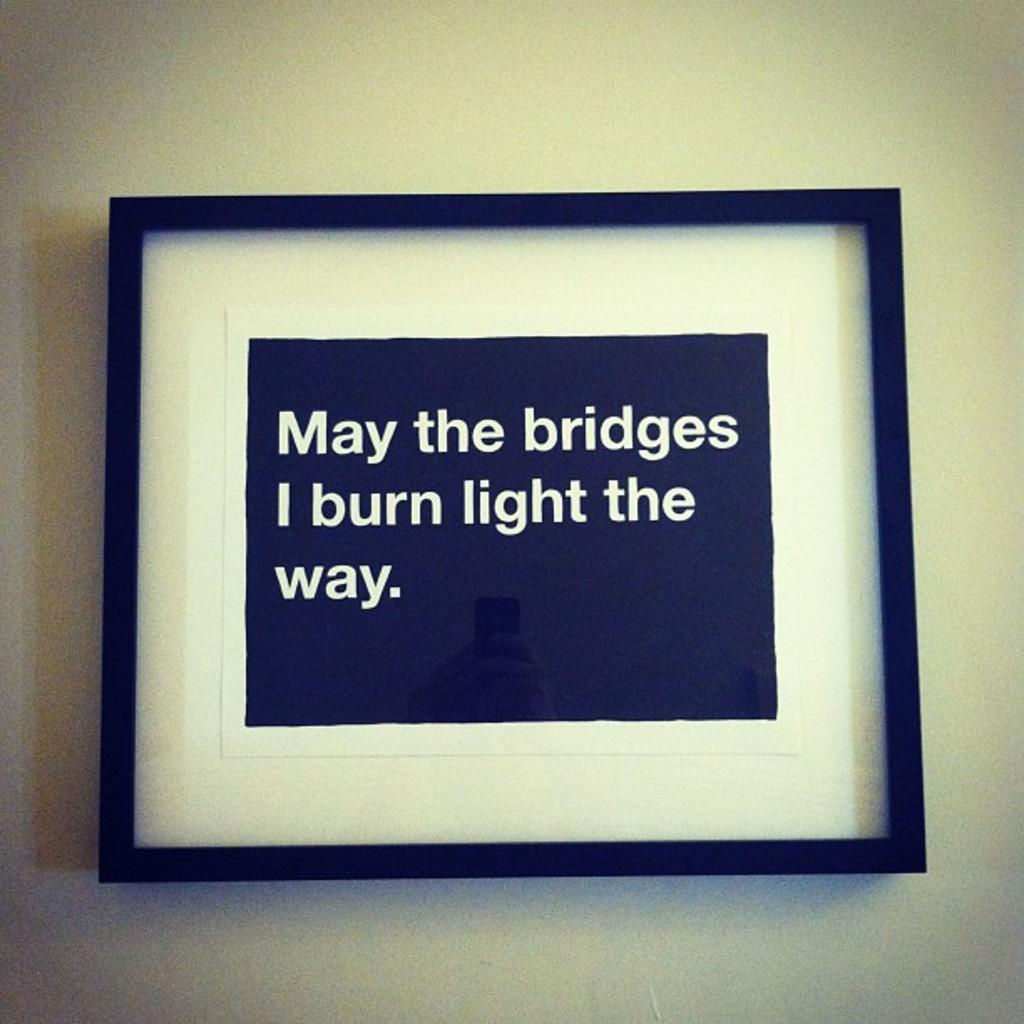<image>
Present a compact description of the photo's key features. A framed image that reads May the bridges I burn light the way. 